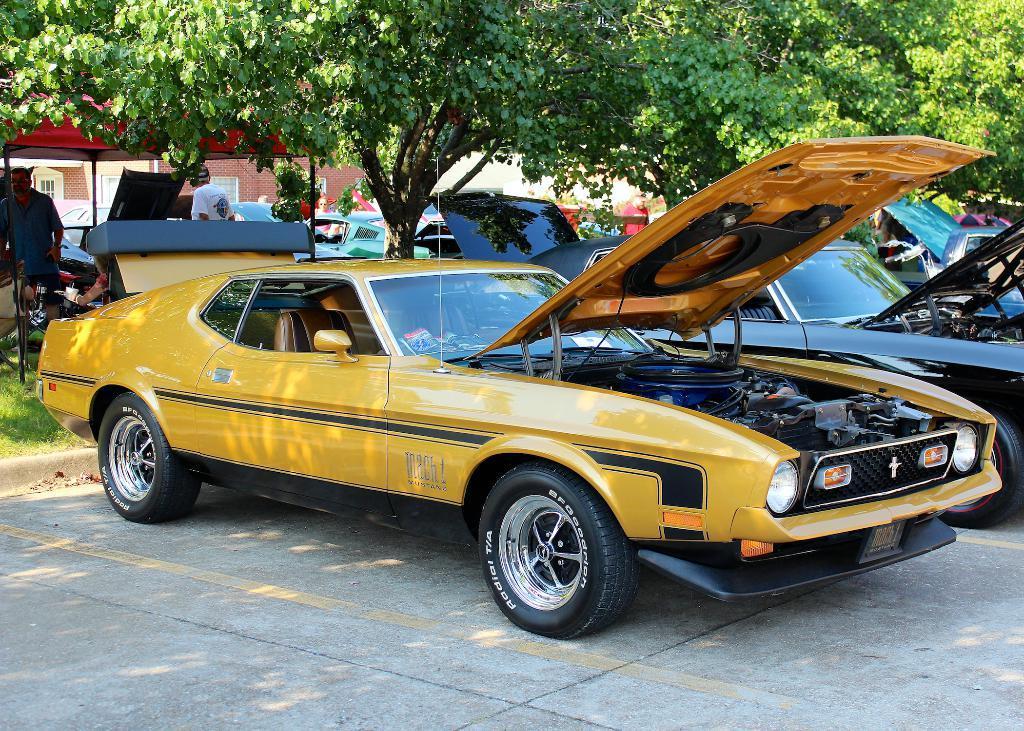Please provide a concise description of this image. In this image, we can see two cars, there are some green color trees, in the background there are two persons standing. 